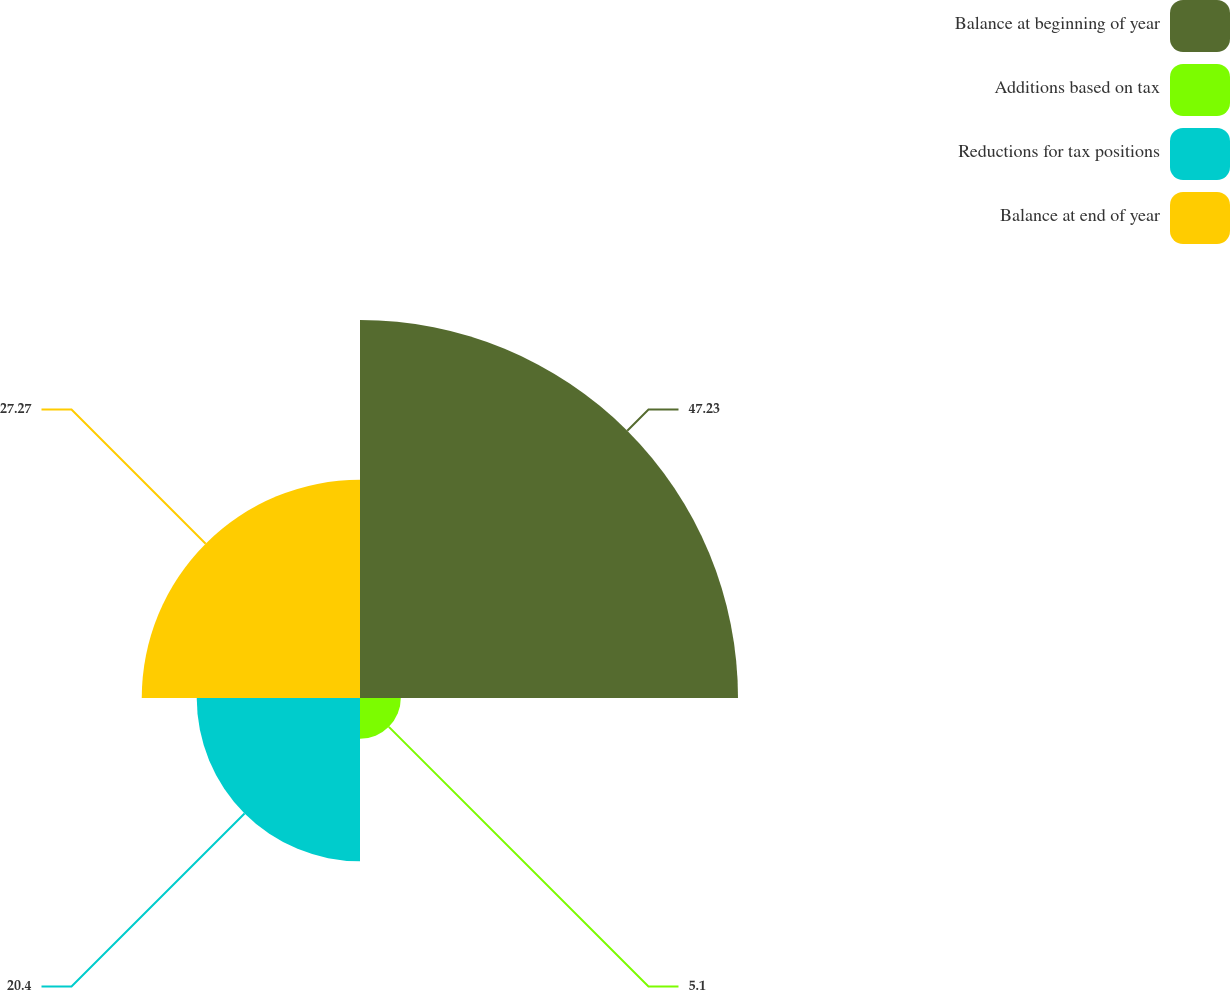Convert chart to OTSL. <chart><loc_0><loc_0><loc_500><loc_500><pie_chart><fcel>Balance at beginning of year<fcel>Additions based on tax<fcel>Reductions for tax positions<fcel>Balance at end of year<nl><fcel>47.23%<fcel>5.1%<fcel>20.4%<fcel>27.27%<nl></chart> 